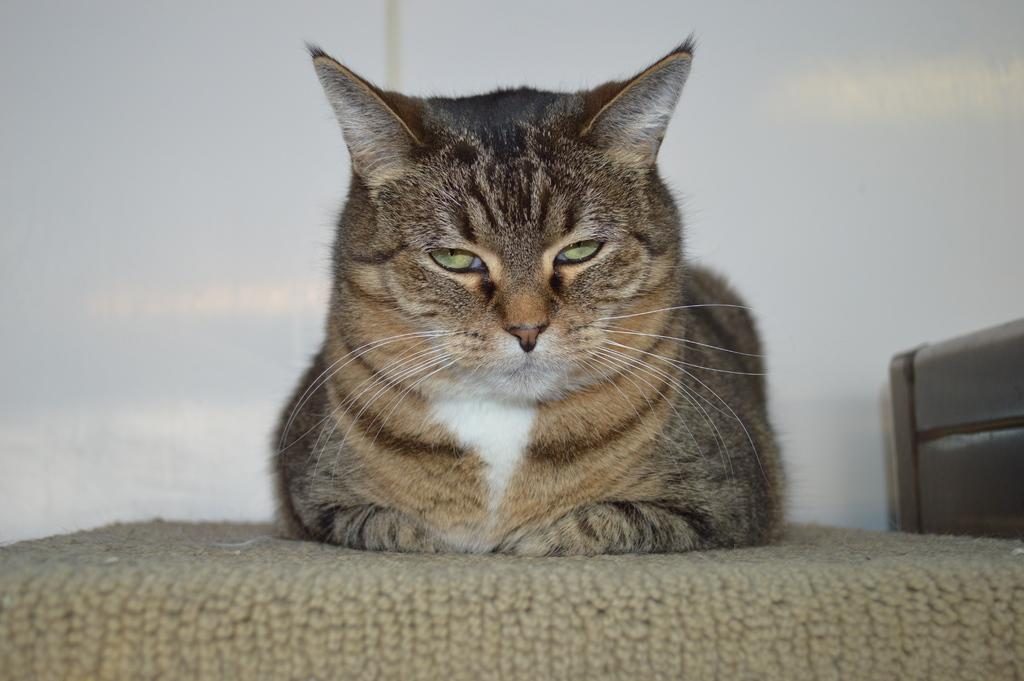What type of animal is present in the image? There is a cat in the image. Where is the cat sitting? The cat is sitting on a cloth surface. What color is the wall in the background of the image? The wall in the background of the image is white. Can you describe any other objects visible in the background? There are other objects visible in the background of the image, but their specific details are not mentioned in the provided facts. What type of whip is the cat using to crack in the image? There is no whip present in the image; the cat is simply sitting on a cloth surface. 